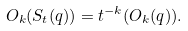Convert formula to latex. <formula><loc_0><loc_0><loc_500><loc_500>O _ { k } ( S _ { t } ( q ) ) = t ^ { - k } ( O _ { k } ( q ) ) .</formula> 